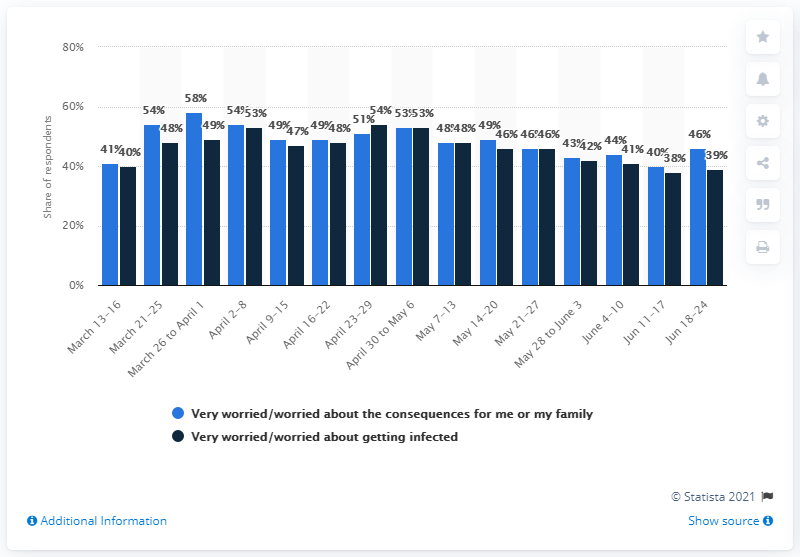Identify some key points in this picture. According to a survey conducted between June 18 and June 24, 46% of Swedes expressed concern about the coronavirus. 